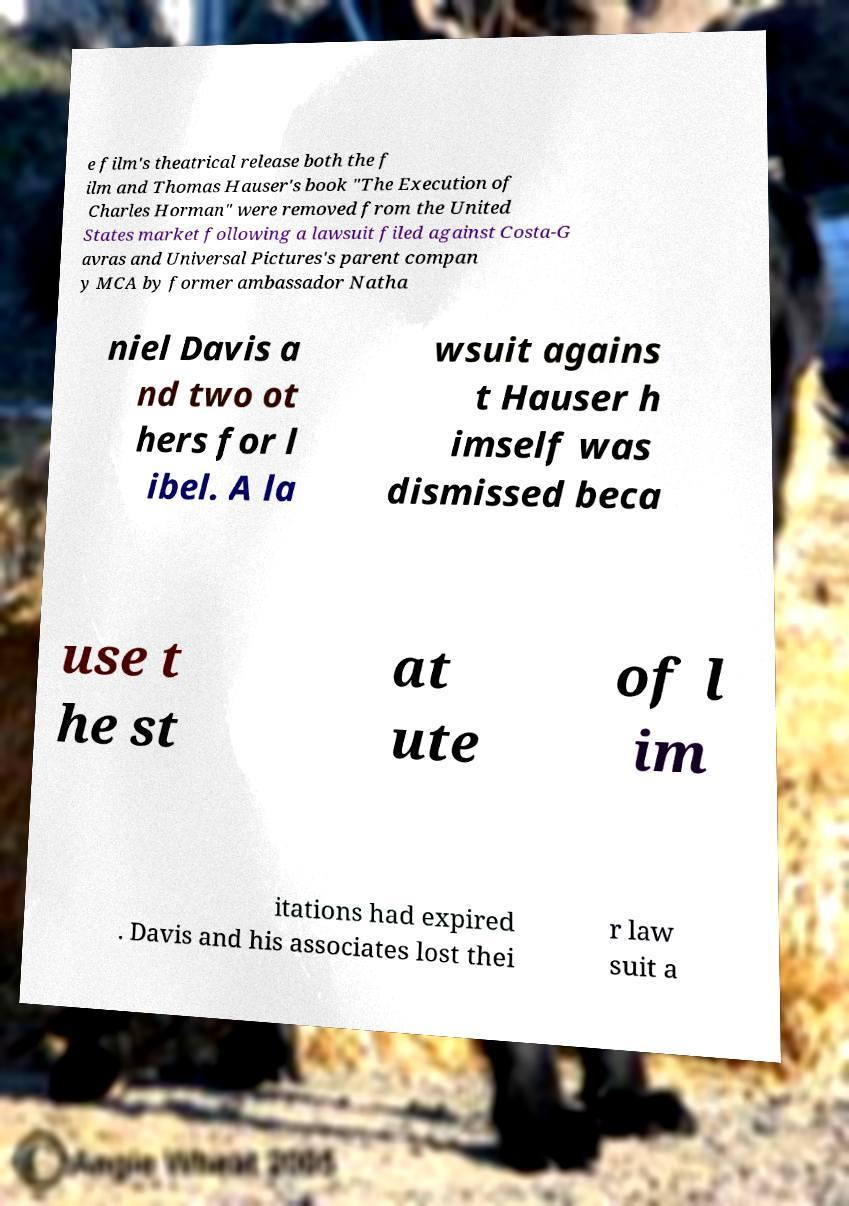What messages or text are displayed in this image? I need them in a readable, typed format. e film's theatrical release both the f ilm and Thomas Hauser's book "The Execution of Charles Horman" were removed from the United States market following a lawsuit filed against Costa-G avras and Universal Pictures's parent compan y MCA by former ambassador Natha niel Davis a nd two ot hers for l ibel. A la wsuit agains t Hauser h imself was dismissed beca use t he st at ute of l im itations had expired . Davis and his associates lost thei r law suit a 